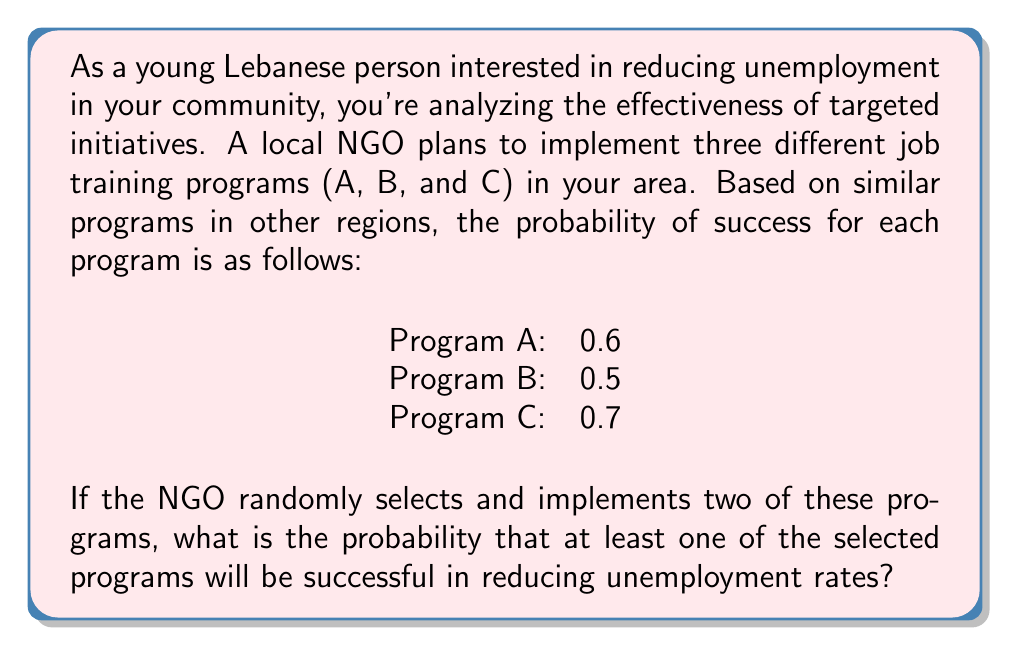Could you help me with this problem? Let's approach this step-by-step:

1) First, we need to calculate the probability of selecting any two programs out of the three. There are three possible combinations:
   (A and B), (A and C), or (B and C)

2) Now, let's calculate the probability of success for each combination:

   For (A and B):
   P(at least one succeeds) = 1 - P(both fail)
   $$ P(A \text{ or } B) = 1 - (1-0.6)(1-0.5) = 1 - 0.4 \times 0.5 = 1 - 0.2 = 0.8 $$

   For (A and C):
   $$ P(A \text{ or } C) = 1 - (1-0.6)(1-0.7) = 1 - 0.4 \times 0.3 = 1 - 0.12 = 0.88 $$

   For (B and C):
   $$ P(B \text{ or } C) = 1 - (1-0.5)(1-0.7) = 1 - 0.5 \times 0.3 = 1 - 0.15 = 0.85 $$

3) Since the NGO is randomly selecting two programs, each combination has an equal probability of being chosen, which is $\frac{1}{3}$.

4) To find the overall probability, we calculate the weighted average:

$$ P(\text{success}) = \frac{1}{3} \times 0.8 + \frac{1}{3} \times 0.88 + \frac{1}{3} \times 0.85 $$

5) Simplifying:

$$ P(\text{success}) = \frac{0.8 + 0.88 + 0.85}{3} = \frac{2.53}{3} \approx 0.8433 $$

Thus, the probability that at least one of the selected programs will be successful in reducing unemployment rates is approximately 0.8433 or 84.33%.
Answer: The probability that at least one of the two randomly selected programs will be successful in reducing unemployment rates is approximately 0.8433 or 84.33%. 